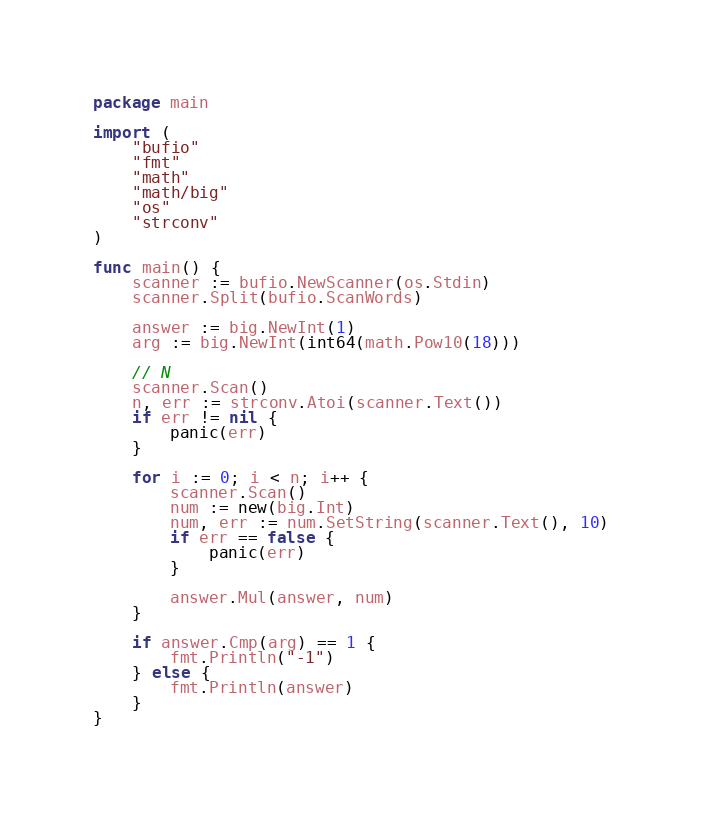<code> <loc_0><loc_0><loc_500><loc_500><_Go_>package main

import (
	"bufio"
	"fmt"
	"math"
	"math/big"
	"os"
	"strconv"
)

func main() {
	scanner := bufio.NewScanner(os.Stdin)
	scanner.Split(bufio.ScanWords)

	answer := big.NewInt(1)
	arg := big.NewInt(int64(math.Pow10(18)))

	// N
	scanner.Scan()
	n, err := strconv.Atoi(scanner.Text())
	if err != nil {
		panic(err)
	}

	for i := 0; i < n; i++ {
		scanner.Scan()
		num := new(big.Int)
		num, err := num.SetString(scanner.Text(), 10)
		if err == false {
			panic(err)
		}

		answer.Mul(answer, num)
	}

	if answer.Cmp(arg) == 1 {
		fmt.Println("-1")
	} else {
		fmt.Println(answer)
	}
}
</code> 